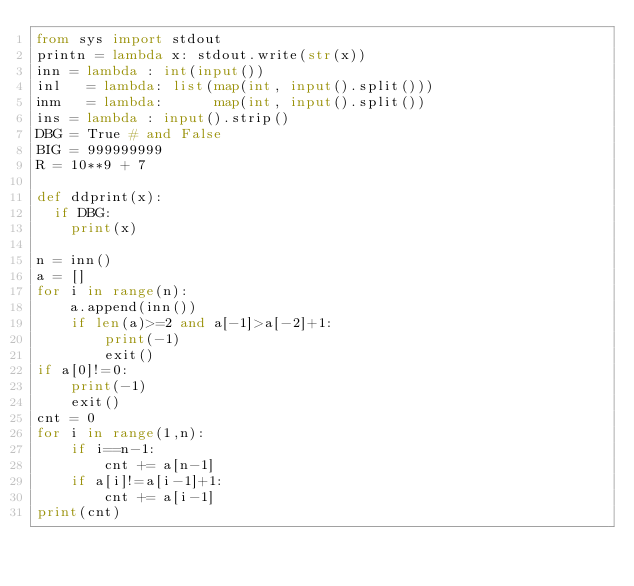<code> <loc_0><loc_0><loc_500><loc_500><_Python_>from sys import stdout
printn = lambda x: stdout.write(str(x))
inn = lambda : int(input())
inl   = lambda: list(map(int, input().split()))
inm   = lambda:      map(int, input().split())
ins = lambda : input().strip()
DBG = True # and False
BIG = 999999999
R = 10**9 + 7

def ddprint(x):
  if DBG:
    print(x)

n = inn()
a = []
for i in range(n):
    a.append(inn())
    if len(a)>=2 and a[-1]>a[-2]+1:
        print(-1)
        exit()
if a[0]!=0:
    print(-1)
    exit()
cnt = 0
for i in range(1,n):
    if i==n-1:
        cnt += a[n-1]
    if a[i]!=a[i-1]+1:
        cnt += a[i-1]
print(cnt)
</code> 